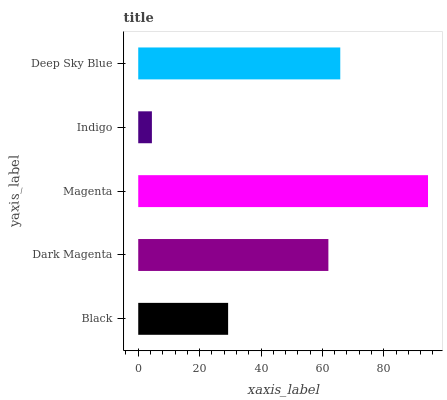Is Indigo the minimum?
Answer yes or no. Yes. Is Magenta the maximum?
Answer yes or no. Yes. Is Dark Magenta the minimum?
Answer yes or no. No. Is Dark Magenta the maximum?
Answer yes or no. No. Is Dark Magenta greater than Black?
Answer yes or no. Yes. Is Black less than Dark Magenta?
Answer yes or no. Yes. Is Black greater than Dark Magenta?
Answer yes or no. No. Is Dark Magenta less than Black?
Answer yes or no. No. Is Dark Magenta the high median?
Answer yes or no. Yes. Is Dark Magenta the low median?
Answer yes or no. Yes. Is Indigo the high median?
Answer yes or no. No. Is Deep Sky Blue the low median?
Answer yes or no. No. 